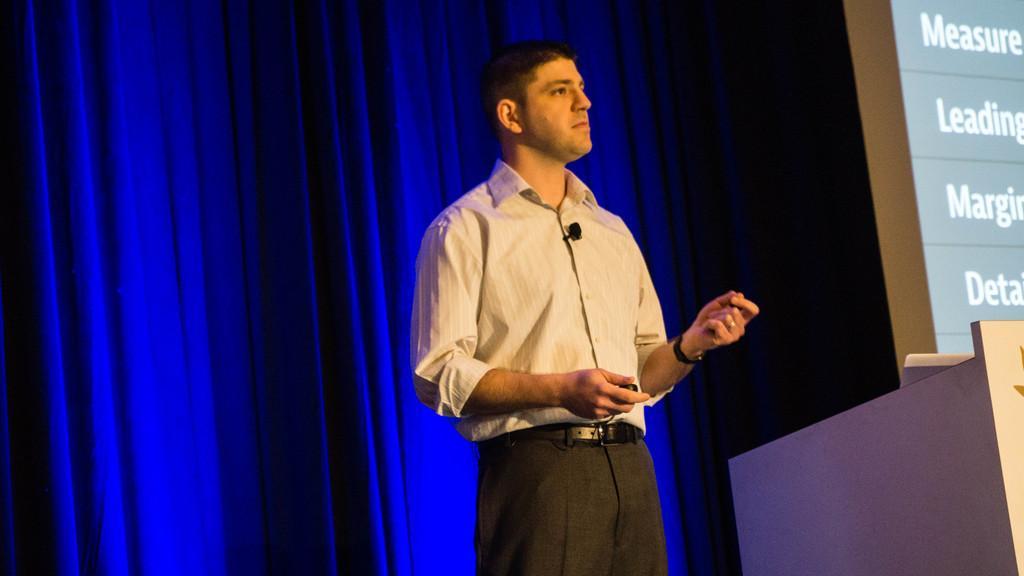How would you summarize this image in a sentence or two? In this image there is a person standing in front of the podium. Behind him there are curtains. There is a screen with text on it. 